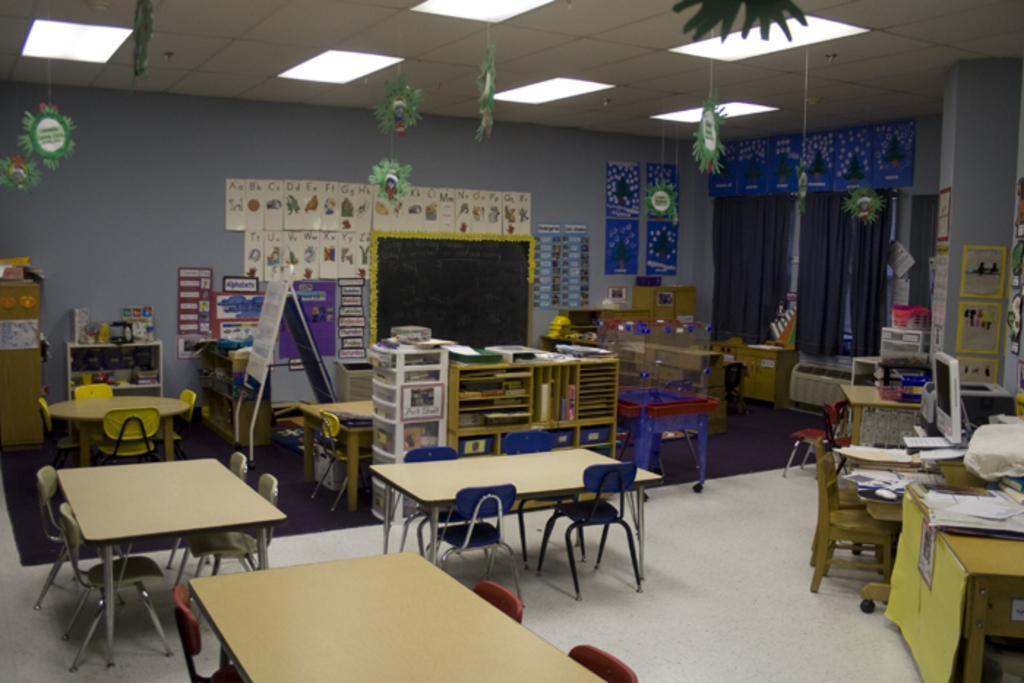How would you summarize this image in a sentence or two? In this image I can see many tables and chairs, in front the chairs are in blue color. Background I can see few papers, books in the cupboard. Background I can see few papers attached to the wall and the wall is in gray color. I can also see a black color board, right side I can see a system on the table. 